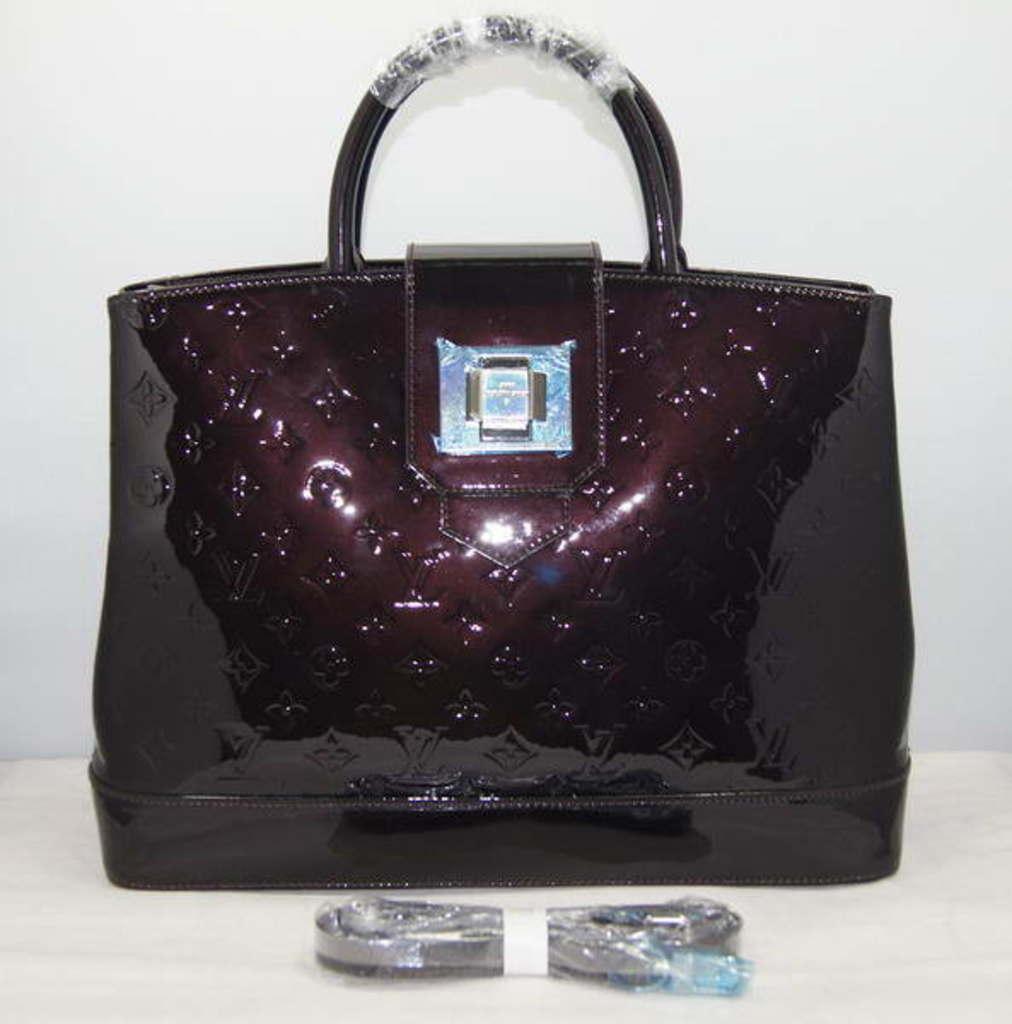Describe this image in one or two sentences. This is a bag with a handle is kept on a table and there is some other item kept on the table. 